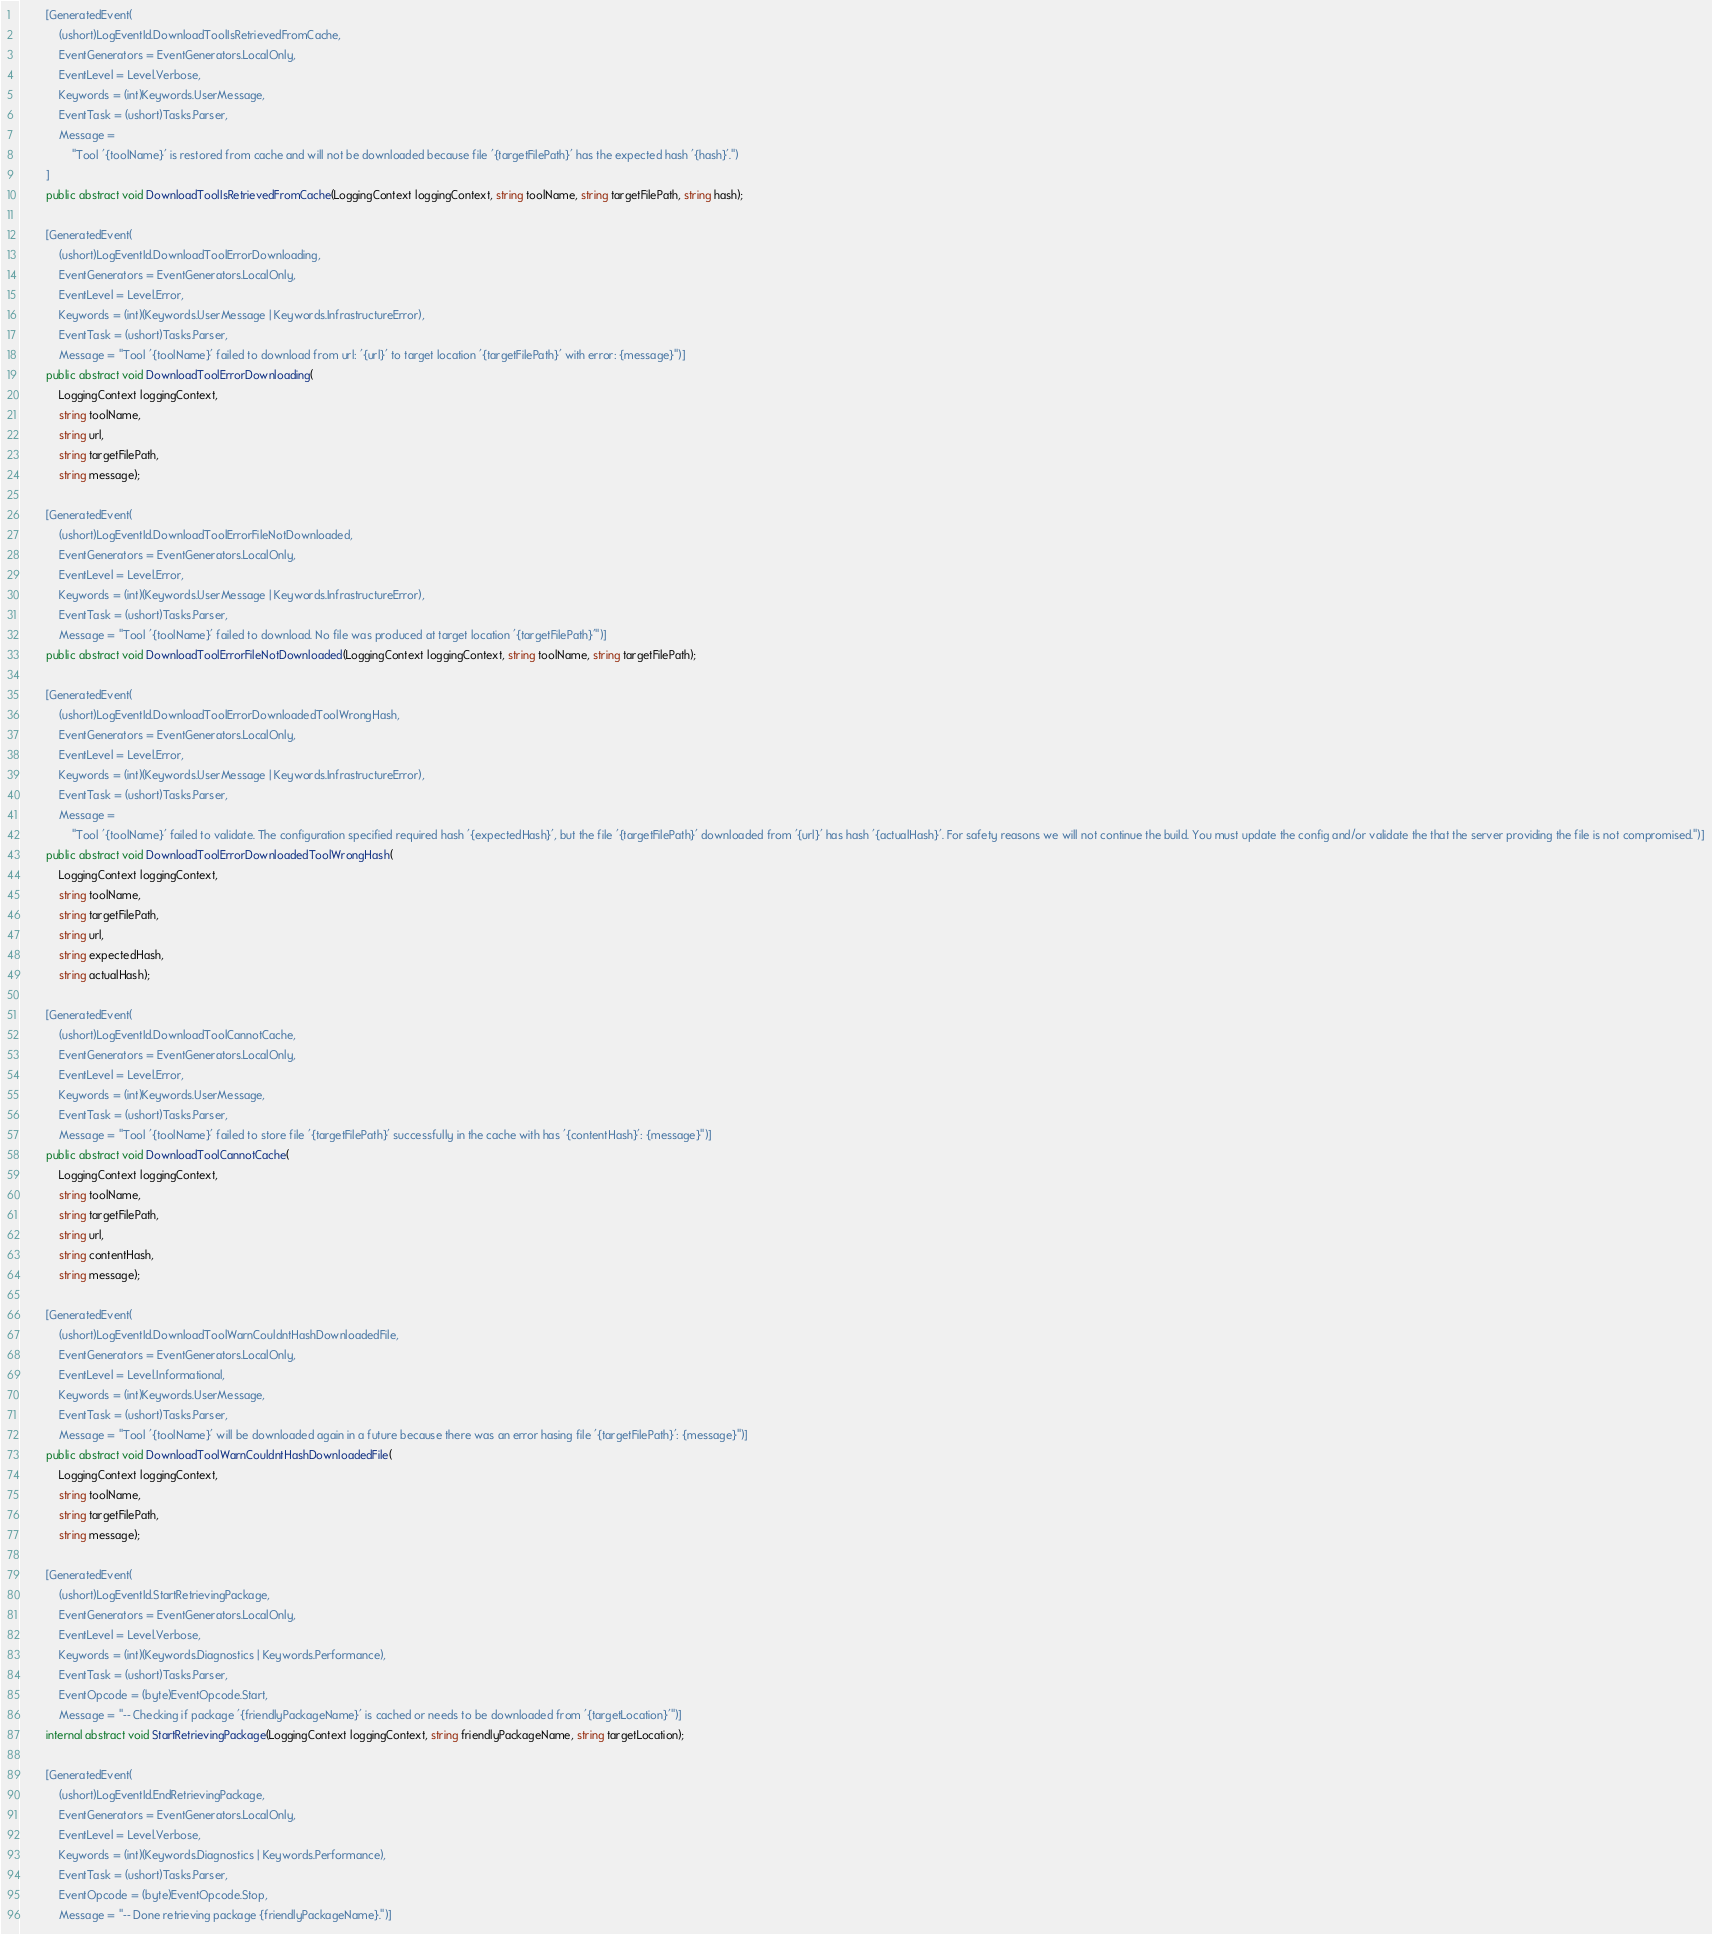<code> <loc_0><loc_0><loc_500><loc_500><_C#_>
        [GeneratedEvent(
            (ushort)LogEventId.DownloadToolIsRetrievedFromCache,
            EventGenerators = EventGenerators.LocalOnly,
            EventLevel = Level.Verbose,
            Keywords = (int)Keywords.UserMessage,
            EventTask = (ushort)Tasks.Parser,
            Message =
                "Tool '{toolName}' is restored from cache and will not be downloaded because file '{targetFilePath}' has the expected hash '{hash}'.")
        ]
        public abstract void DownloadToolIsRetrievedFromCache(LoggingContext loggingContext, string toolName, string targetFilePath, string hash);

        [GeneratedEvent(
            (ushort)LogEventId.DownloadToolErrorDownloading,
            EventGenerators = EventGenerators.LocalOnly,
            EventLevel = Level.Error,
            Keywords = (int)(Keywords.UserMessage | Keywords.InfrastructureError),
            EventTask = (ushort)Tasks.Parser,
            Message = "Tool '{toolName}' failed to download from url: '{url}' to target location '{targetFilePath}' with error: {message}")]
        public abstract void DownloadToolErrorDownloading(
            LoggingContext loggingContext,
            string toolName,
            string url,
            string targetFilePath,
            string message);

        [GeneratedEvent(
            (ushort)LogEventId.DownloadToolErrorFileNotDownloaded,
            EventGenerators = EventGenerators.LocalOnly,
            EventLevel = Level.Error,
            Keywords = (int)(Keywords.UserMessage | Keywords.InfrastructureError),
            EventTask = (ushort)Tasks.Parser,
            Message = "Tool '{toolName}' failed to download. No file was produced at target location '{targetFilePath}'")]
        public abstract void DownloadToolErrorFileNotDownloaded(LoggingContext loggingContext, string toolName, string targetFilePath);

        [GeneratedEvent(
            (ushort)LogEventId.DownloadToolErrorDownloadedToolWrongHash,
            EventGenerators = EventGenerators.LocalOnly,
            EventLevel = Level.Error,
            Keywords = (int)(Keywords.UserMessage | Keywords.InfrastructureError),
            EventTask = (ushort)Tasks.Parser,
            Message =
                "Tool '{toolName}' failed to validate. The configuration specified required hash '{expectedHash}', but the file '{targetFilePath}' downloaded from '{url}' has hash '{actualHash}'. For safety reasons we will not continue the build. You must update the config and/or validate the that the server providing the file is not compromised.")]
        public abstract void DownloadToolErrorDownloadedToolWrongHash(
            LoggingContext loggingContext,
            string toolName,
            string targetFilePath,
            string url,
            string expectedHash,
            string actualHash);

        [GeneratedEvent(
            (ushort)LogEventId.DownloadToolCannotCache,
            EventGenerators = EventGenerators.LocalOnly,
            EventLevel = Level.Error,
            Keywords = (int)Keywords.UserMessage,
            EventTask = (ushort)Tasks.Parser,
            Message = "Tool '{toolName}' failed to store file '{targetFilePath}' successfully in the cache with has '{contentHash}': {message}")]
        public abstract void DownloadToolCannotCache(
            LoggingContext loggingContext,
            string toolName,
            string targetFilePath,
            string url,
            string contentHash,
            string message);

        [GeneratedEvent(
            (ushort)LogEventId.DownloadToolWarnCouldntHashDownloadedFile,
            EventGenerators = EventGenerators.LocalOnly,
            EventLevel = Level.Informational,
            Keywords = (int)Keywords.UserMessage,
            EventTask = (ushort)Tasks.Parser,
            Message = "Tool '{toolName}' will be downloaded again in a future because there was an error hasing file '{targetFilePath}': {message}")]
        public abstract void DownloadToolWarnCouldntHashDownloadedFile(
            LoggingContext loggingContext,
            string toolName,
            string targetFilePath,
            string message);

        [GeneratedEvent(
            (ushort)LogEventId.StartRetrievingPackage,
            EventGenerators = EventGenerators.LocalOnly,
            EventLevel = Level.Verbose,
            Keywords = (int)(Keywords.Diagnostics | Keywords.Performance),
            EventTask = (ushort)Tasks.Parser,
            EventOpcode = (byte)EventOpcode.Start,
            Message = "-- Checking if package '{friendlyPackageName}' is cached or needs to be downloaded from '{targetLocation}'")]
        internal abstract void StartRetrievingPackage(LoggingContext loggingContext, string friendlyPackageName, string targetLocation);

        [GeneratedEvent(
            (ushort)LogEventId.EndRetrievingPackage,
            EventGenerators = EventGenerators.LocalOnly,
            EventLevel = Level.Verbose,
            Keywords = (int)(Keywords.Diagnostics | Keywords.Performance),
            EventTask = (ushort)Tasks.Parser,
            EventOpcode = (byte)EventOpcode.Stop,
            Message = "-- Done retrieving package {friendlyPackageName}.")]</code> 